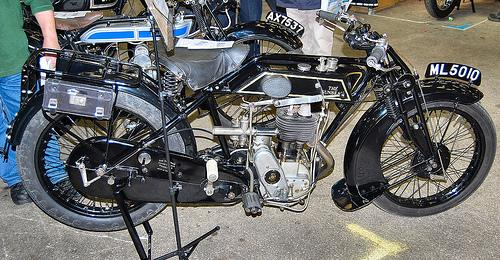Outline the image's main subject by mentioning its fundamental features and the context in which it is presented. A vintage black motorcycle, complete with tires, engine, handlebars, and a kickstand, is displayed at a show or in a museum as part of a collection. Compose a short explanation of the central object in the image, covering its primary attributes and its current situation. The showcased old fashioned black motorcycle, parked on concrete and equipped with various parts, is an antique available for purchase or admiration. Create a brief visual summary of the primary object in the image, including its key characteristics and significance. The antique black motorcycle, featuring various parts such as tires, engine, handlebars, and a kickstand, is a collector’s item being showcased in a display. Provide a brief description of the primary object in the image and its primary features. An old fashioned motorcycle with front and back tires, an engine, handlebars, a seat, a gas tank, a license plate, and a kickstand is displayed. In a single sentence, describe the appearance and setting of the principal subject of the image. The antique black motorcycle with motor, handlebars, and tires is exhibited in a museum or a collector's show on a concrete ground. Describe the main object in the image and its key features while highlighting its context and purpose. A collector's antique black motorcycle with essential parts such as motor, tires, handlebars, and a kickstand is exhibited for sale at a show or in a museum. Narrate the visual story of the primary element in the image, including its purpose and connection to its surroundings. The motorcycle, a vintage black model with motor and various parts, is presented in a museum or show, attracting attention as a collector’s item. Summarize the visual details of the main subject in the image, incorporating their most notable characteristics. The antique motorcycle, featuring a black color scheme, motor, handlebars, and tires, is parked on concrete and showcased as part of a collection. In one sentence, express the primary function of the object in the image and its overall appearance. The old black motorcycle, complete with handlebars, tires, and an engine, is exhibited for sale, showcasing its antique status and pristine condition. Provide a concise overview of the main subject in the image along with the context of its location and ownership. An antique motorcycle, belonging to a collector, is on display and for sale, featuring a black body with a motor, handlebars, tires, and a kickstand. 